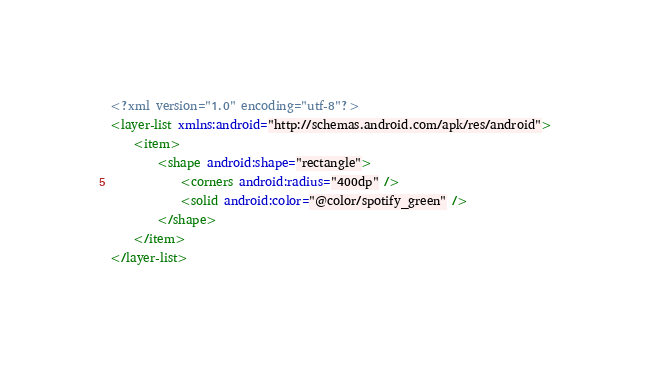<code> <loc_0><loc_0><loc_500><loc_500><_XML_><?xml version="1.0" encoding="utf-8"?>
<layer-list xmlns:android="http://schemas.android.com/apk/res/android">
    <item>
        <shape android:shape="rectangle">
            <corners android:radius="400dp" />
            <solid android:color="@color/spotify_green" />
        </shape>
    </item>
</layer-list></code> 